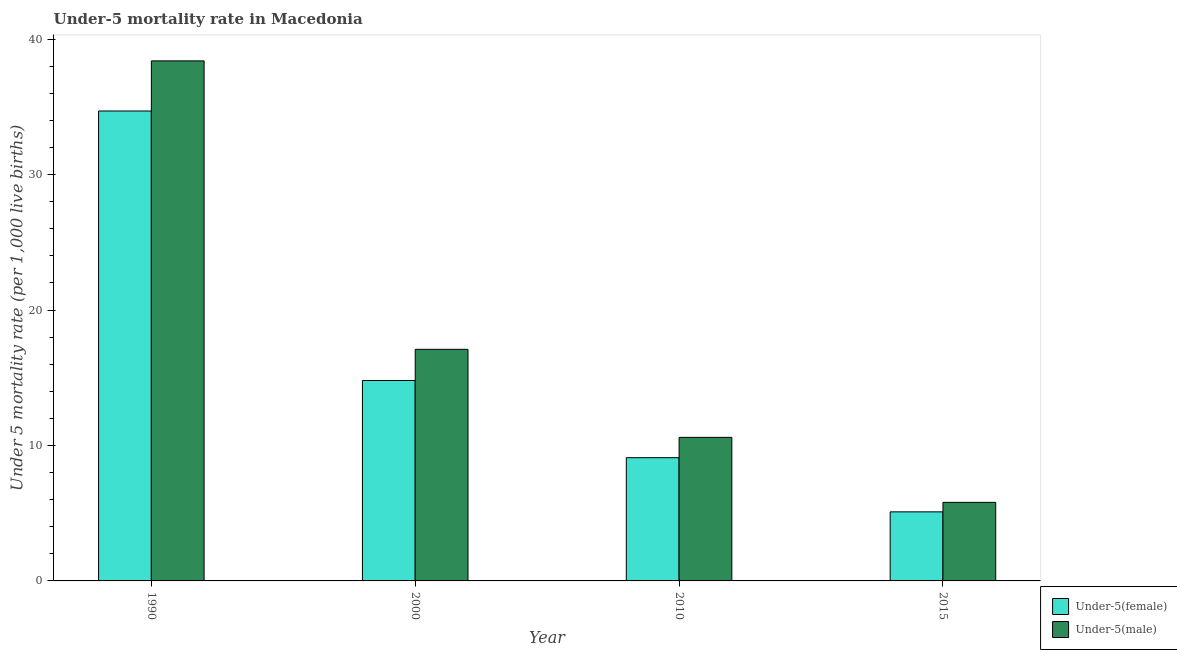How many different coloured bars are there?
Make the answer very short. 2. How many bars are there on the 2nd tick from the right?
Give a very brief answer. 2. In how many cases, is the number of bars for a given year not equal to the number of legend labels?
Ensure brevity in your answer.  0. What is the under-5 female mortality rate in 2015?
Make the answer very short. 5.1. Across all years, what is the maximum under-5 female mortality rate?
Provide a succinct answer. 34.7. In which year was the under-5 female mortality rate minimum?
Offer a very short reply. 2015. What is the total under-5 male mortality rate in the graph?
Make the answer very short. 71.9. What is the difference between the under-5 female mortality rate in 1990 and the under-5 male mortality rate in 2015?
Give a very brief answer. 29.6. What is the average under-5 female mortality rate per year?
Your answer should be compact. 15.93. What is the ratio of the under-5 male mortality rate in 1990 to that in 2000?
Your answer should be compact. 2.25. Is the difference between the under-5 male mortality rate in 1990 and 2000 greater than the difference between the under-5 female mortality rate in 1990 and 2000?
Make the answer very short. No. What is the difference between the highest and the second highest under-5 male mortality rate?
Ensure brevity in your answer.  21.3. What is the difference between the highest and the lowest under-5 female mortality rate?
Give a very brief answer. 29.6. What does the 2nd bar from the left in 2000 represents?
Give a very brief answer. Under-5(male). What does the 2nd bar from the right in 2010 represents?
Your answer should be compact. Under-5(female). Are all the bars in the graph horizontal?
Offer a terse response. No. What is the difference between two consecutive major ticks on the Y-axis?
Your answer should be very brief. 10. Are the values on the major ticks of Y-axis written in scientific E-notation?
Offer a terse response. No. Does the graph contain any zero values?
Ensure brevity in your answer.  No. Where does the legend appear in the graph?
Give a very brief answer. Bottom right. How many legend labels are there?
Your answer should be compact. 2. How are the legend labels stacked?
Offer a very short reply. Vertical. What is the title of the graph?
Your answer should be compact. Under-5 mortality rate in Macedonia. What is the label or title of the X-axis?
Provide a short and direct response. Year. What is the label or title of the Y-axis?
Provide a succinct answer. Under 5 mortality rate (per 1,0 live births). What is the Under 5 mortality rate (per 1,000 live births) of Under-5(female) in 1990?
Give a very brief answer. 34.7. What is the Under 5 mortality rate (per 1,000 live births) of Under-5(male) in 1990?
Keep it short and to the point. 38.4. What is the Under 5 mortality rate (per 1,000 live births) in Under-5(female) in 2000?
Provide a succinct answer. 14.8. What is the Under 5 mortality rate (per 1,000 live births) in Under-5(male) in 2015?
Your response must be concise. 5.8. Across all years, what is the maximum Under 5 mortality rate (per 1,000 live births) of Under-5(female)?
Your answer should be very brief. 34.7. Across all years, what is the maximum Under 5 mortality rate (per 1,000 live births) in Under-5(male)?
Your answer should be compact. 38.4. What is the total Under 5 mortality rate (per 1,000 live births) of Under-5(female) in the graph?
Provide a succinct answer. 63.7. What is the total Under 5 mortality rate (per 1,000 live births) of Under-5(male) in the graph?
Keep it short and to the point. 71.9. What is the difference between the Under 5 mortality rate (per 1,000 live births) in Under-5(male) in 1990 and that in 2000?
Your answer should be very brief. 21.3. What is the difference between the Under 5 mortality rate (per 1,000 live births) of Under-5(female) in 1990 and that in 2010?
Provide a short and direct response. 25.6. What is the difference between the Under 5 mortality rate (per 1,000 live births) of Under-5(male) in 1990 and that in 2010?
Keep it short and to the point. 27.8. What is the difference between the Under 5 mortality rate (per 1,000 live births) in Under-5(female) in 1990 and that in 2015?
Your answer should be compact. 29.6. What is the difference between the Under 5 mortality rate (per 1,000 live births) of Under-5(male) in 1990 and that in 2015?
Provide a succinct answer. 32.6. What is the difference between the Under 5 mortality rate (per 1,000 live births) of Under-5(female) in 2000 and that in 2010?
Offer a terse response. 5.7. What is the difference between the Under 5 mortality rate (per 1,000 live births) of Under-5(female) in 2000 and that in 2015?
Ensure brevity in your answer.  9.7. What is the difference between the Under 5 mortality rate (per 1,000 live births) of Under-5(female) in 1990 and the Under 5 mortality rate (per 1,000 live births) of Under-5(male) in 2010?
Your answer should be compact. 24.1. What is the difference between the Under 5 mortality rate (per 1,000 live births) of Under-5(female) in 1990 and the Under 5 mortality rate (per 1,000 live births) of Under-5(male) in 2015?
Give a very brief answer. 28.9. What is the difference between the Under 5 mortality rate (per 1,000 live births) of Under-5(female) in 2000 and the Under 5 mortality rate (per 1,000 live births) of Under-5(male) in 2010?
Ensure brevity in your answer.  4.2. What is the difference between the Under 5 mortality rate (per 1,000 live births) of Under-5(female) in 2000 and the Under 5 mortality rate (per 1,000 live births) of Under-5(male) in 2015?
Make the answer very short. 9. What is the difference between the Under 5 mortality rate (per 1,000 live births) of Under-5(female) in 2010 and the Under 5 mortality rate (per 1,000 live births) of Under-5(male) in 2015?
Ensure brevity in your answer.  3.3. What is the average Under 5 mortality rate (per 1,000 live births) of Under-5(female) per year?
Provide a short and direct response. 15.93. What is the average Under 5 mortality rate (per 1,000 live births) of Under-5(male) per year?
Your answer should be compact. 17.98. In the year 1990, what is the difference between the Under 5 mortality rate (per 1,000 live births) of Under-5(female) and Under 5 mortality rate (per 1,000 live births) of Under-5(male)?
Your response must be concise. -3.7. In the year 2000, what is the difference between the Under 5 mortality rate (per 1,000 live births) in Under-5(female) and Under 5 mortality rate (per 1,000 live births) in Under-5(male)?
Offer a terse response. -2.3. In the year 2015, what is the difference between the Under 5 mortality rate (per 1,000 live births) of Under-5(female) and Under 5 mortality rate (per 1,000 live births) of Under-5(male)?
Your answer should be compact. -0.7. What is the ratio of the Under 5 mortality rate (per 1,000 live births) of Under-5(female) in 1990 to that in 2000?
Make the answer very short. 2.34. What is the ratio of the Under 5 mortality rate (per 1,000 live births) of Under-5(male) in 1990 to that in 2000?
Provide a short and direct response. 2.25. What is the ratio of the Under 5 mortality rate (per 1,000 live births) in Under-5(female) in 1990 to that in 2010?
Provide a succinct answer. 3.81. What is the ratio of the Under 5 mortality rate (per 1,000 live births) of Under-5(male) in 1990 to that in 2010?
Offer a very short reply. 3.62. What is the ratio of the Under 5 mortality rate (per 1,000 live births) in Under-5(female) in 1990 to that in 2015?
Give a very brief answer. 6.8. What is the ratio of the Under 5 mortality rate (per 1,000 live births) of Under-5(male) in 1990 to that in 2015?
Give a very brief answer. 6.62. What is the ratio of the Under 5 mortality rate (per 1,000 live births) of Under-5(female) in 2000 to that in 2010?
Your answer should be very brief. 1.63. What is the ratio of the Under 5 mortality rate (per 1,000 live births) in Under-5(male) in 2000 to that in 2010?
Give a very brief answer. 1.61. What is the ratio of the Under 5 mortality rate (per 1,000 live births) of Under-5(female) in 2000 to that in 2015?
Your answer should be very brief. 2.9. What is the ratio of the Under 5 mortality rate (per 1,000 live births) of Under-5(male) in 2000 to that in 2015?
Your answer should be very brief. 2.95. What is the ratio of the Under 5 mortality rate (per 1,000 live births) in Under-5(female) in 2010 to that in 2015?
Offer a terse response. 1.78. What is the ratio of the Under 5 mortality rate (per 1,000 live births) of Under-5(male) in 2010 to that in 2015?
Provide a short and direct response. 1.83. What is the difference between the highest and the second highest Under 5 mortality rate (per 1,000 live births) of Under-5(female)?
Your answer should be compact. 19.9. What is the difference between the highest and the second highest Under 5 mortality rate (per 1,000 live births) of Under-5(male)?
Offer a terse response. 21.3. What is the difference between the highest and the lowest Under 5 mortality rate (per 1,000 live births) in Under-5(female)?
Make the answer very short. 29.6. What is the difference between the highest and the lowest Under 5 mortality rate (per 1,000 live births) of Under-5(male)?
Provide a short and direct response. 32.6. 